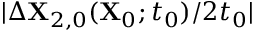Convert formula to latex. <formula><loc_0><loc_0><loc_500><loc_500>| \Delta X _ { 2 , 0 } ( X _ { 0 } ; t _ { 0 } ) / 2 t _ { 0 } |</formula> 